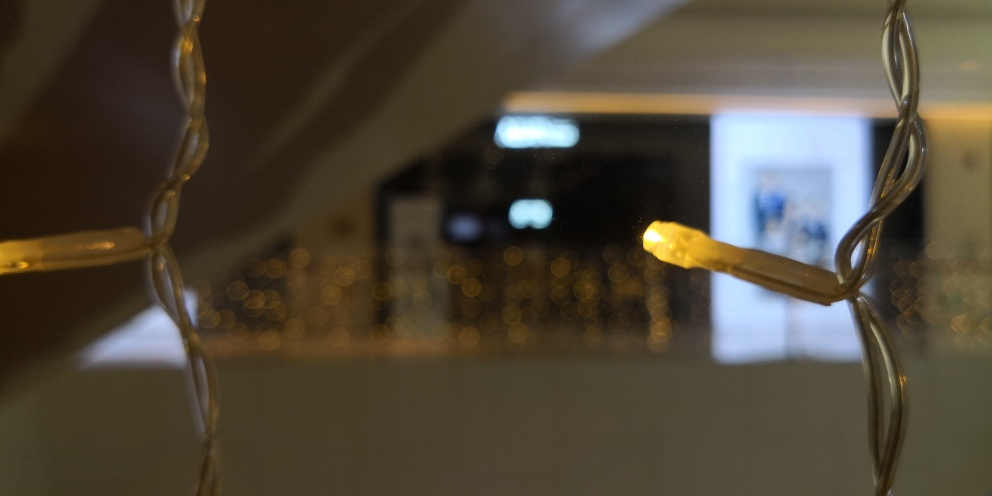Can you describe how the depth of field technique affects the image? The use of a shallow depth of field technique in this image, where only a narrow plane is in clear focus, draws attention to the lit string of lights and creates a soft blur in the background. This artistic choice adds depth, isolates the subject, and can trigger curiosity about the indistinct shapes and context behind the focused area. 